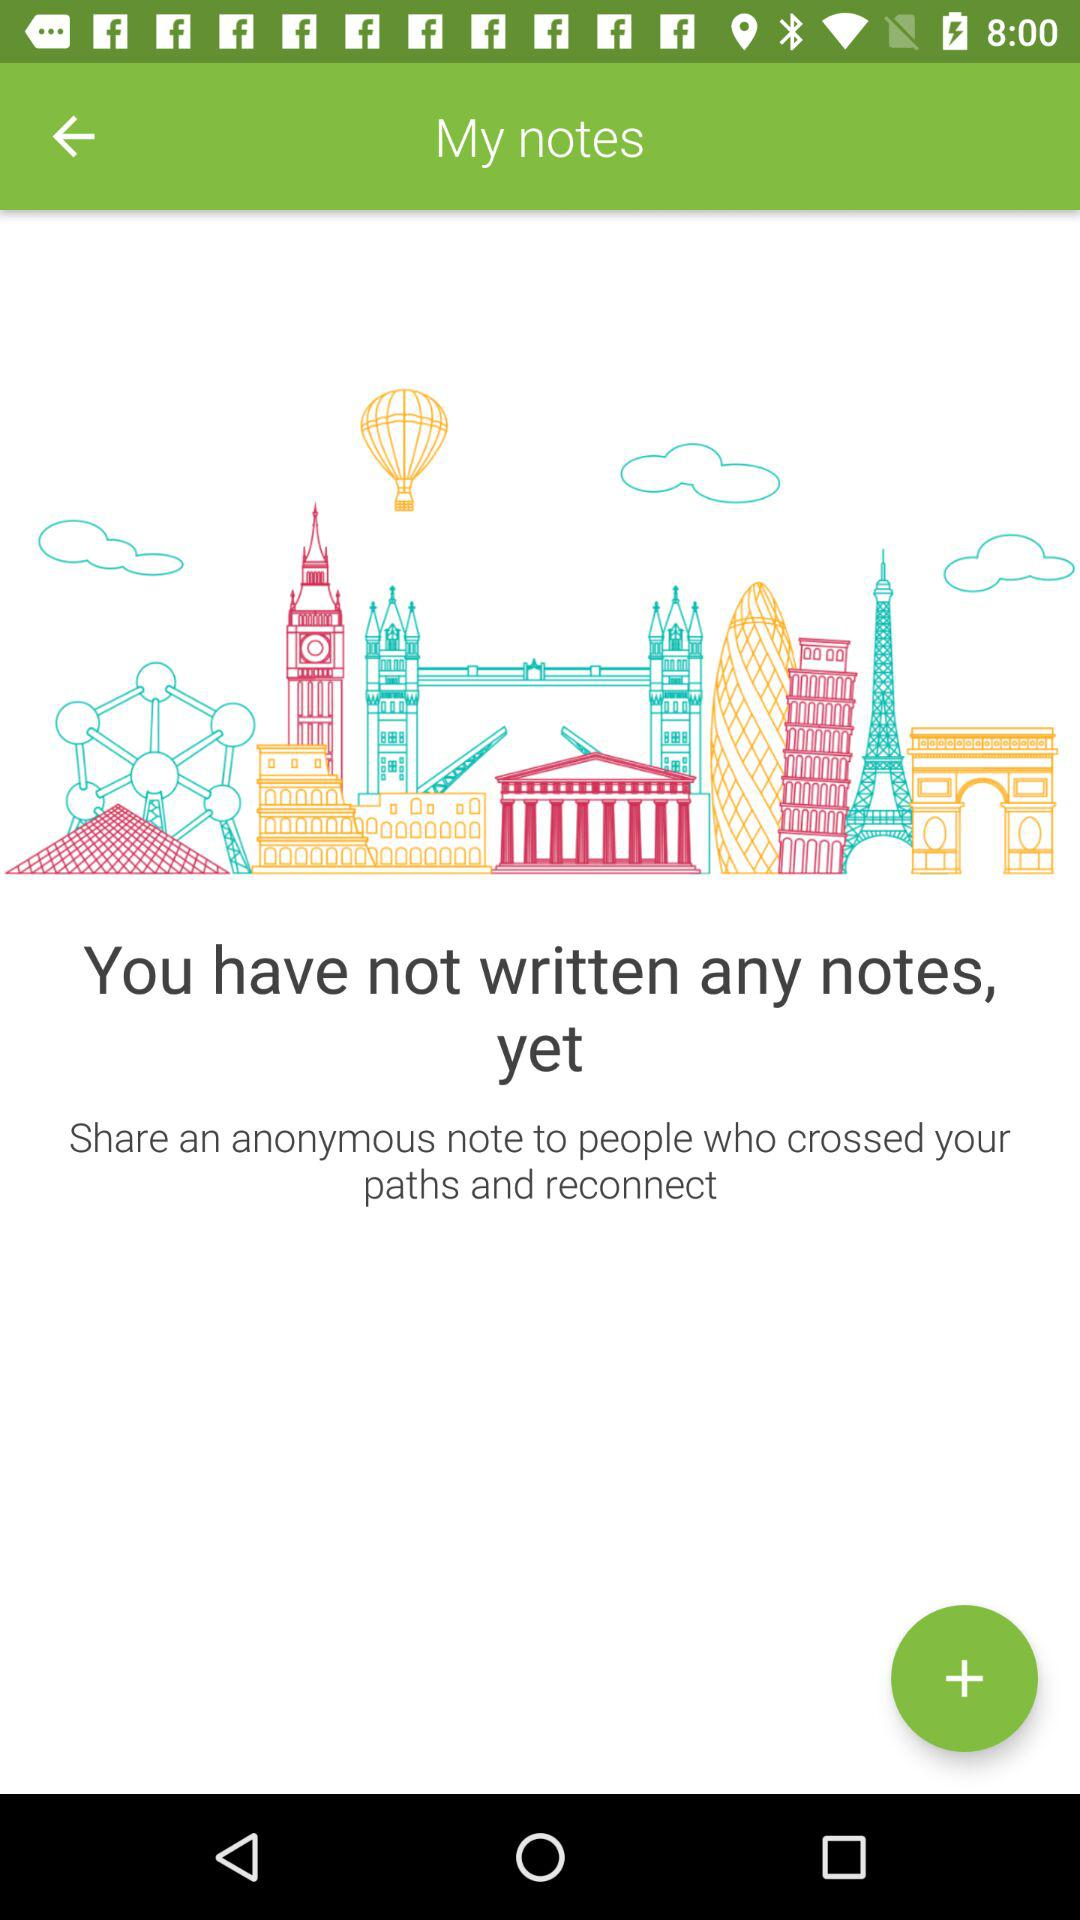How many notes can fit into the application?
When the provided information is insufficient, respond with <no answer>. <no answer> 